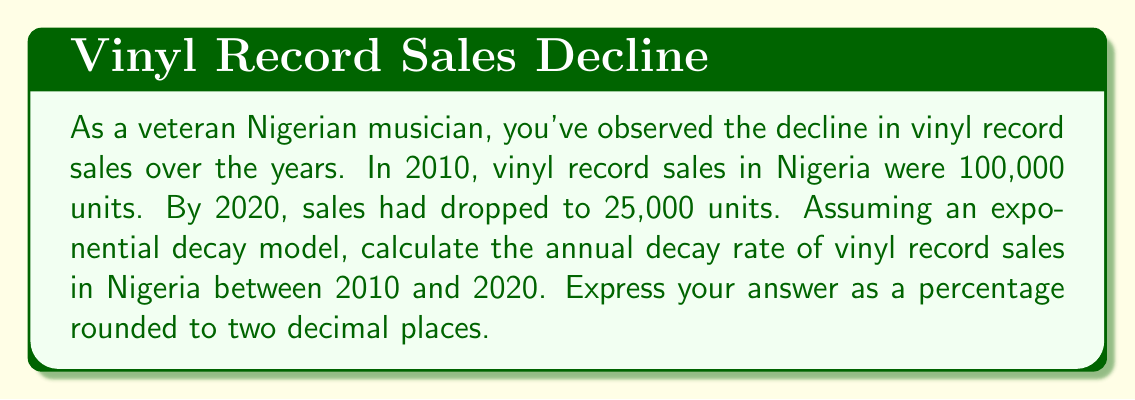Solve this math problem. To solve this problem, we'll use the exponential decay formula:

$$A(t) = A_0 \cdot (1-r)^t$$

Where:
$A(t)$ is the amount at time $t$
$A_0$ is the initial amount
$r$ is the decay rate
$t$ is the time period

We know:
$A_0 = 100,000$ (initial sales in 2010)
$A(10) = 25,000$ (sales after 10 years in 2020)
$t = 10$ years

Let's plug these values into the formula:

$$25,000 = 100,000 \cdot (1-r)^{10}$$

Dividing both sides by 100,000:

$$0.25 = (1-r)^{10}$$

Taking the 10th root of both sides:

$$\sqrt[10]{0.25} = 1-r$$

$$\sqrt[10]{0.25} \approx 0.8705$$

Now we can solve for $r$:

$$1 - 0.8705 = r$$
$$r \approx 0.1295$$

To convert to a percentage, we multiply by 100:

$$r \approx 0.1295 \cdot 100 = 12.95\%$$

Rounding to two decimal places, we get 12.95%.
Answer: 12.95% 